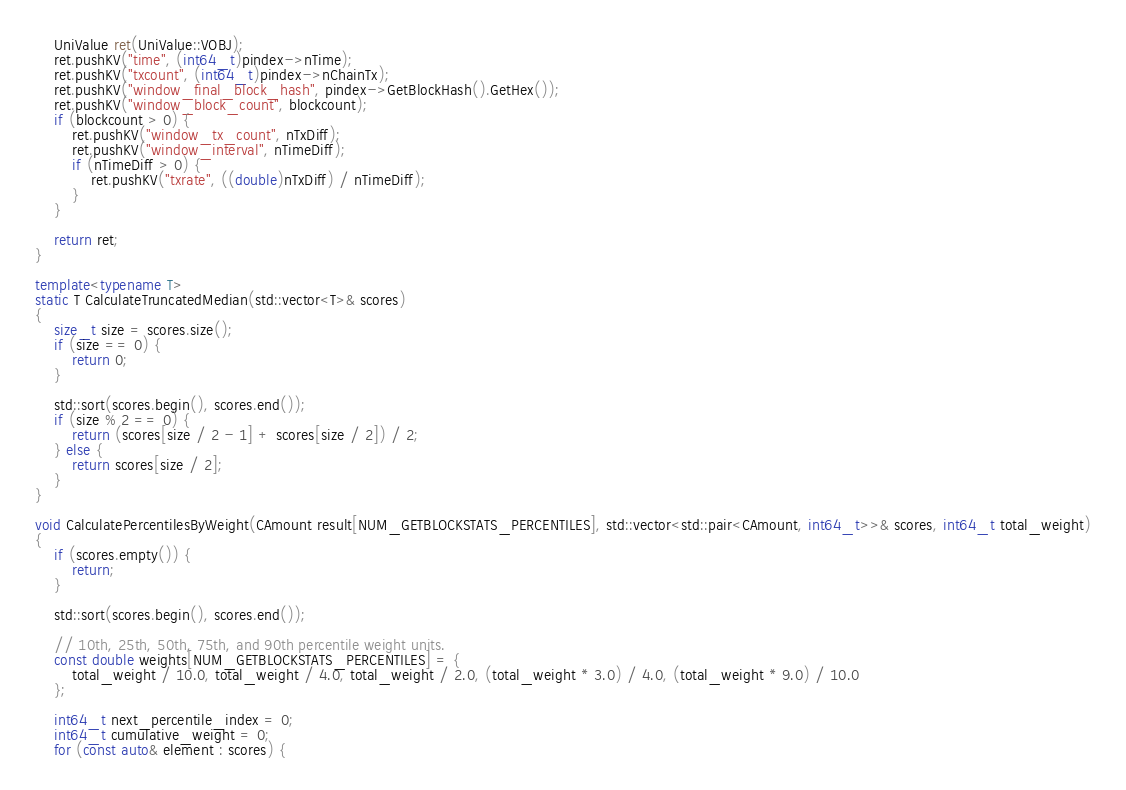Convert code to text. <code><loc_0><loc_0><loc_500><loc_500><_C++_>
    UniValue ret(UniValue::VOBJ);
    ret.pushKV("time", (int64_t)pindex->nTime);
    ret.pushKV("txcount", (int64_t)pindex->nChainTx);
    ret.pushKV("window_final_block_hash", pindex->GetBlockHash().GetHex());
    ret.pushKV("window_block_count", blockcount);
    if (blockcount > 0) {
        ret.pushKV("window_tx_count", nTxDiff);
        ret.pushKV("window_interval", nTimeDiff);
        if (nTimeDiff > 0) {
            ret.pushKV("txrate", ((double)nTxDiff) / nTimeDiff);
        }
    }

    return ret;
}

template<typename T>
static T CalculateTruncatedMedian(std::vector<T>& scores)
{
    size_t size = scores.size();
    if (size == 0) {
        return 0;
    }

    std::sort(scores.begin(), scores.end());
    if (size % 2 == 0) {
        return (scores[size / 2 - 1] + scores[size / 2]) / 2;
    } else {
        return scores[size / 2];
    }
}

void CalculatePercentilesByWeight(CAmount result[NUM_GETBLOCKSTATS_PERCENTILES], std::vector<std::pair<CAmount, int64_t>>& scores, int64_t total_weight)
{
    if (scores.empty()) {
        return;
    }

    std::sort(scores.begin(), scores.end());

    // 10th, 25th, 50th, 75th, and 90th percentile weight units.
    const double weights[NUM_GETBLOCKSTATS_PERCENTILES] = {
        total_weight / 10.0, total_weight / 4.0, total_weight / 2.0, (total_weight * 3.0) / 4.0, (total_weight * 9.0) / 10.0
    };

    int64_t next_percentile_index = 0;
    int64_t cumulative_weight = 0;
    for (const auto& element : scores) {</code> 